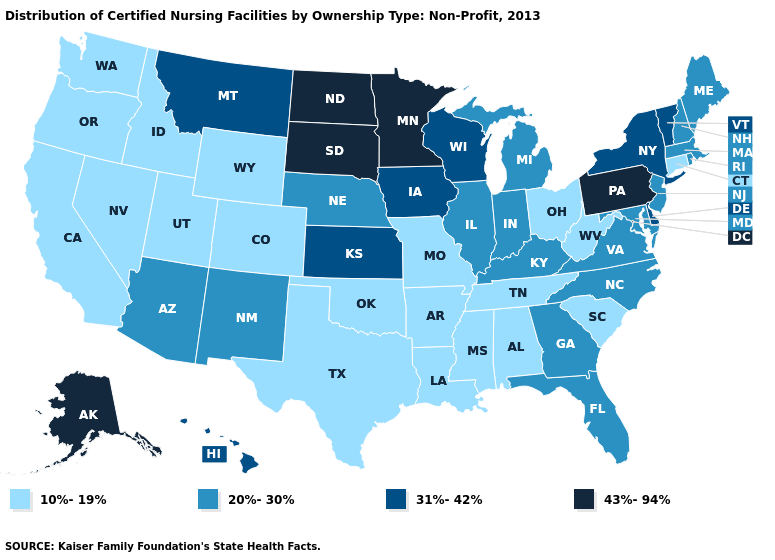What is the value of Virginia?
Give a very brief answer. 20%-30%. Does the first symbol in the legend represent the smallest category?
Answer briefly. Yes. Does Kansas have the lowest value in the USA?
Write a very short answer. No. Which states have the highest value in the USA?
Give a very brief answer. Alaska, Minnesota, North Dakota, Pennsylvania, South Dakota. Name the states that have a value in the range 20%-30%?
Concise answer only. Arizona, Florida, Georgia, Illinois, Indiana, Kentucky, Maine, Maryland, Massachusetts, Michigan, Nebraska, New Hampshire, New Jersey, New Mexico, North Carolina, Rhode Island, Virginia. What is the value of Iowa?
Answer briefly. 31%-42%. What is the lowest value in states that border Montana?
Quick response, please. 10%-19%. Does the first symbol in the legend represent the smallest category?
Keep it brief. Yes. What is the highest value in the USA?
Keep it brief. 43%-94%. Name the states that have a value in the range 31%-42%?
Be succinct. Delaware, Hawaii, Iowa, Kansas, Montana, New York, Vermont, Wisconsin. Name the states that have a value in the range 20%-30%?
Give a very brief answer. Arizona, Florida, Georgia, Illinois, Indiana, Kentucky, Maine, Maryland, Massachusetts, Michigan, Nebraska, New Hampshire, New Jersey, New Mexico, North Carolina, Rhode Island, Virginia. Does California have the lowest value in the USA?
Quick response, please. Yes. Which states have the lowest value in the MidWest?
Write a very short answer. Missouri, Ohio. Name the states that have a value in the range 20%-30%?
Answer briefly. Arizona, Florida, Georgia, Illinois, Indiana, Kentucky, Maine, Maryland, Massachusetts, Michigan, Nebraska, New Hampshire, New Jersey, New Mexico, North Carolina, Rhode Island, Virginia. What is the lowest value in the USA?
Concise answer only. 10%-19%. 